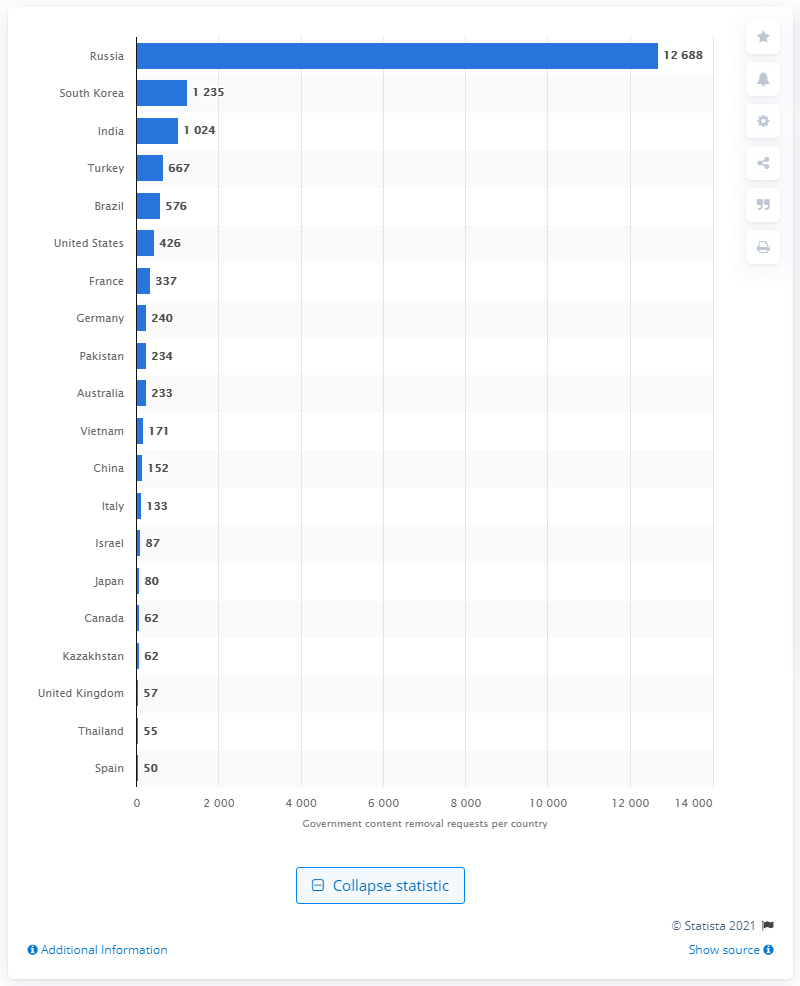Outline some significant characteristics in this image. Russia was the most prolific content removal requester in the first half of 2020. The United States received 426 content removal requests in the first half of 2020. South Korea was ranked second with 1,235 content removal requests. 